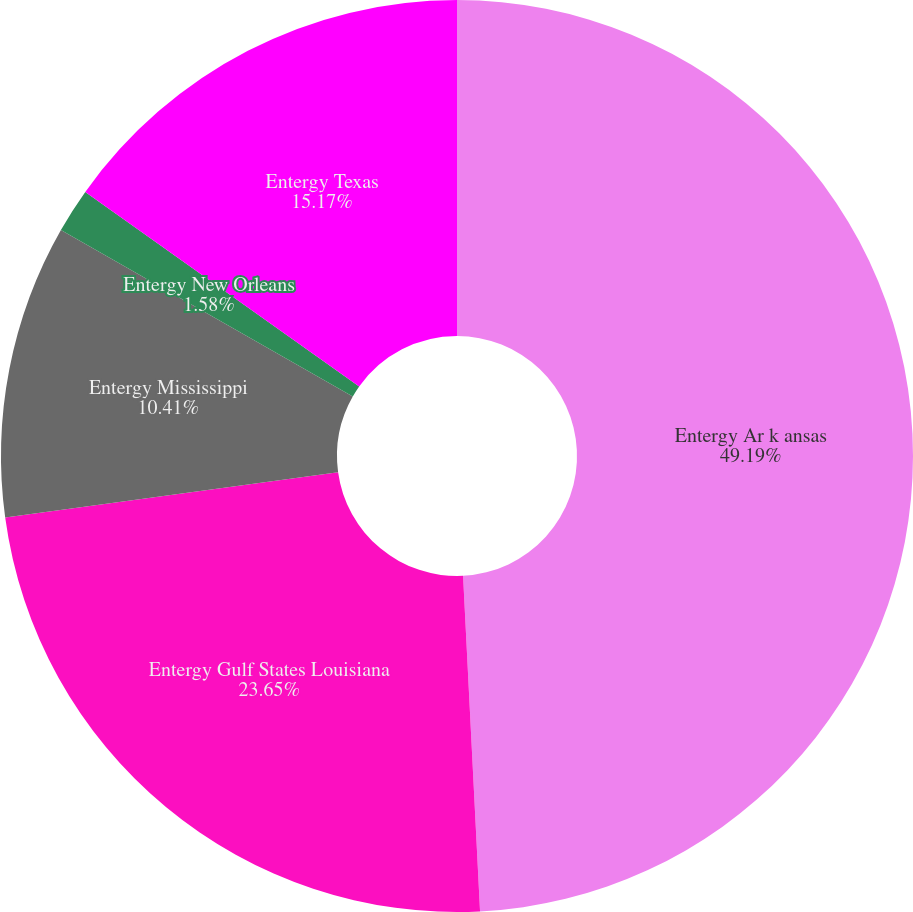Convert chart. <chart><loc_0><loc_0><loc_500><loc_500><pie_chart><fcel>Entergy Ar k ansas<fcel>Entergy Gulf States Louisiana<fcel>Entergy Mississippi<fcel>Entergy New Orleans<fcel>Entergy Texas<nl><fcel>49.2%<fcel>23.65%<fcel>10.41%<fcel>1.58%<fcel>15.17%<nl></chart> 